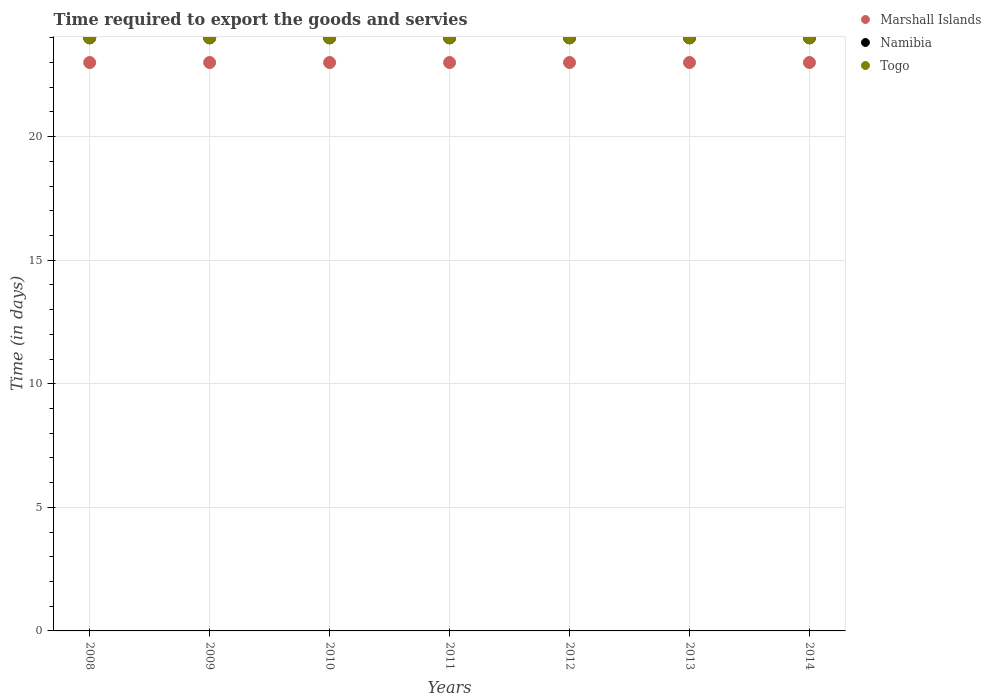What is the number of days required to export the goods and services in Namibia in 2014?
Give a very brief answer. 24. Across all years, what is the maximum number of days required to export the goods and services in Togo?
Your answer should be very brief. 24. Across all years, what is the minimum number of days required to export the goods and services in Marshall Islands?
Your response must be concise. 23. In which year was the number of days required to export the goods and services in Namibia minimum?
Keep it short and to the point. 2008. What is the total number of days required to export the goods and services in Togo in the graph?
Offer a very short reply. 168. What is the difference between the number of days required to export the goods and services in Togo in 2010 and that in 2013?
Your response must be concise. 0. What is the average number of days required to export the goods and services in Marshall Islands per year?
Provide a succinct answer. 23. In the year 2013, what is the difference between the number of days required to export the goods and services in Marshall Islands and number of days required to export the goods and services in Namibia?
Offer a terse response. -1. In how many years, is the number of days required to export the goods and services in Namibia greater than 6 days?
Make the answer very short. 7. What is the ratio of the number of days required to export the goods and services in Marshall Islands in 2008 to that in 2013?
Offer a terse response. 1. Is the difference between the number of days required to export the goods and services in Marshall Islands in 2012 and 2014 greater than the difference between the number of days required to export the goods and services in Namibia in 2012 and 2014?
Give a very brief answer. No. What is the difference between the highest and the lowest number of days required to export the goods and services in Namibia?
Provide a short and direct response. 0. Is the number of days required to export the goods and services in Togo strictly greater than the number of days required to export the goods and services in Namibia over the years?
Your answer should be very brief. No. How many dotlines are there?
Keep it short and to the point. 3. How many years are there in the graph?
Keep it short and to the point. 7. What is the difference between two consecutive major ticks on the Y-axis?
Provide a succinct answer. 5. Are the values on the major ticks of Y-axis written in scientific E-notation?
Your response must be concise. No. Does the graph contain grids?
Provide a short and direct response. Yes. Where does the legend appear in the graph?
Provide a short and direct response. Top right. How many legend labels are there?
Provide a short and direct response. 3. How are the legend labels stacked?
Make the answer very short. Vertical. What is the title of the graph?
Your response must be concise. Time required to export the goods and servies. Does "Vietnam" appear as one of the legend labels in the graph?
Your answer should be compact. No. What is the label or title of the Y-axis?
Your answer should be very brief. Time (in days). What is the Time (in days) in Namibia in 2008?
Offer a terse response. 24. What is the Time (in days) in Togo in 2008?
Keep it short and to the point. 24. What is the Time (in days) of Togo in 2009?
Provide a short and direct response. 24. What is the Time (in days) of Marshall Islands in 2010?
Give a very brief answer. 23. What is the Time (in days) in Namibia in 2010?
Your response must be concise. 24. What is the Time (in days) of Togo in 2010?
Offer a terse response. 24. What is the Time (in days) in Marshall Islands in 2011?
Provide a succinct answer. 23. What is the Time (in days) of Togo in 2011?
Provide a succinct answer. 24. What is the Time (in days) of Marshall Islands in 2012?
Offer a terse response. 23. What is the Time (in days) of Togo in 2012?
Your answer should be very brief. 24. What is the Time (in days) in Namibia in 2013?
Offer a very short reply. 24. What is the Time (in days) of Togo in 2013?
Offer a very short reply. 24. What is the Time (in days) of Marshall Islands in 2014?
Provide a succinct answer. 23. What is the Time (in days) in Namibia in 2014?
Offer a terse response. 24. Across all years, what is the maximum Time (in days) of Marshall Islands?
Your answer should be very brief. 23. Across all years, what is the maximum Time (in days) of Namibia?
Your answer should be compact. 24. Across all years, what is the minimum Time (in days) of Namibia?
Offer a very short reply. 24. What is the total Time (in days) in Marshall Islands in the graph?
Offer a terse response. 161. What is the total Time (in days) of Namibia in the graph?
Your answer should be very brief. 168. What is the total Time (in days) of Togo in the graph?
Ensure brevity in your answer.  168. What is the difference between the Time (in days) in Namibia in 2008 and that in 2009?
Make the answer very short. 0. What is the difference between the Time (in days) in Togo in 2008 and that in 2009?
Your response must be concise. 0. What is the difference between the Time (in days) in Marshall Islands in 2008 and that in 2010?
Keep it short and to the point. 0. What is the difference between the Time (in days) in Marshall Islands in 2008 and that in 2011?
Your answer should be very brief. 0. What is the difference between the Time (in days) in Togo in 2008 and that in 2011?
Your answer should be compact. 0. What is the difference between the Time (in days) in Marshall Islands in 2008 and that in 2012?
Offer a very short reply. 0. What is the difference between the Time (in days) in Marshall Islands in 2008 and that in 2014?
Your response must be concise. 0. What is the difference between the Time (in days) in Namibia in 2008 and that in 2014?
Keep it short and to the point. 0. What is the difference between the Time (in days) in Togo in 2009 and that in 2010?
Ensure brevity in your answer.  0. What is the difference between the Time (in days) of Marshall Islands in 2009 and that in 2011?
Give a very brief answer. 0. What is the difference between the Time (in days) in Namibia in 2009 and that in 2011?
Provide a short and direct response. 0. What is the difference between the Time (in days) of Togo in 2009 and that in 2011?
Offer a terse response. 0. What is the difference between the Time (in days) in Marshall Islands in 2009 and that in 2012?
Your response must be concise. 0. What is the difference between the Time (in days) of Namibia in 2009 and that in 2012?
Your answer should be compact. 0. What is the difference between the Time (in days) of Togo in 2009 and that in 2012?
Keep it short and to the point. 0. What is the difference between the Time (in days) of Marshall Islands in 2009 and that in 2014?
Make the answer very short. 0. What is the difference between the Time (in days) in Togo in 2009 and that in 2014?
Provide a short and direct response. 0. What is the difference between the Time (in days) of Marshall Islands in 2010 and that in 2012?
Ensure brevity in your answer.  0. What is the difference between the Time (in days) of Namibia in 2010 and that in 2013?
Provide a short and direct response. 0. What is the difference between the Time (in days) in Namibia in 2010 and that in 2014?
Provide a short and direct response. 0. What is the difference between the Time (in days) of Marshall Islands in 2011 and that in 2012?
Provide a succinct answer. 0. What is the difference between the Time (in days) of Marshall Islands in 2011 and that in 2014?
Keep it short and to the point. 0. What is the difference between the Time (in days) in Namibia in 2011 and that in 2014?
Your response must be concise. 0. What is the difference between the Time (in days) in Togo in 2011 and that in 2014?
Provide a short and direct response. 0. What is the difference between the Time (in days) of Marshall Islands in 2012 and that in 2013?
Your answer should be very brief. 0. What is the difference between the Time (in days) of Togo in 2012 and that in 2013?
Ensure brevity in your answer.  0. What is the difference between the Time (in days) of Marshall Islands in 2012 and that in 2014?
Ensure brevity in your answer.  0. What is the difference between the Time (in days) of Togo in 2012 and that in 2014?
Keep it short and to the point. 0. What is the difference between the Time (in days) of Marshall Islands in 2013 and that in 2014?
Provide a succinct answer. 0. What is the difference between the Time (in days) in Namibia in 2013 and that in 2014?
Provide a succinct answer. 0. What is the difference between the Time (in days) in Togo in 2013 and that in 2014?
Offer a terse response. 0. What is the difference between the Time (in days) of Marshall Islands in 2008 and the Time (in days) of Togo in 2009?
Your answer should be compact. -1. What is the difference between the Time (in days) in Namibia in 2008 and the Time (in days) in Togo in 2009?
Keep it short and to the point. 0. What is the difference between the Time (in days) of Marshall Islands in 2008 and the Time (in days) of Namibia in 2010?
Offer a very short reply. -1. What is the difference between the Time (in days) of Marshall Islands in 2008 and the Time (in days) of Togo in 2010?
Make the answer very short. -1. What is the difference between the Time (in days) of Marshall Islands in 2008 and the Time (in days) of Namibia in 2012?
Keep it short and to the point. -1. What is the difference between the Time (in days) of Namibia in 2008 and the Time (in days) of Togo in 2012?
Ensure brevity in your answer.  0. What is the difference between the Time (in days) in Marshall Islands in 2008 and the Time (in days) in Togo in 2013?
Your answer should be compact. -1. What is the difference between the Time (in days) in Namibia in 2008 and the Time (in days) in Togo in 2013?
Provide a succinct answer. 0. What is the difference between the Time (in days) of Marshall Islands in 2008 and the Time (in days) of Namibia in 2014?
Keep it short and to the point. -1. What is the difference between the Time (in days) of Marshall Islands in 2009 and the Time (in days) of Namibia in 2010?
Provide a succinct answer. -1. What is the difference between the Time (in days) in Marshall Islands in 2009 and the Time (in days) in Togo in 2010?
Make the answer very short. -1. What is the difference between the Time (in days) of Namibia in 2009 and the Time (in days) of Togo in 2010?
Your answer should be very brief. 0. What is the difference between the Time (in days) of Marshall Islands in 2009 and the Time (in days) of Namibia in 2011?
Your response must be concise. -1. What is the difference between the Time (in days) in Marshall Islands in 2009 and the Time (in days) in Namibia in 2012?
Ensure brevity in your answer.  -1. What is the difference between the Time (in days) in Namibia in 2009 and the Time (in days) in Togo in 2014?
Provide a short and direct response. 0. What is the difference between the Time (in days) of Namibia in 2010 and the Time (in days) of Togo in 2011?
Provide a succinct answer. 0. What is the difference between the Time (in days) in Namibia in 2010 and the Time (in days) in Togo in 2012?
Provide a succinct answer. 0. What is the difference between the Time (in days) in Marshall Islands in 2010 and the Time (in days) in Namibia in 2013?
Your answer should be compact. -1. What is the difference between the Time (in days) in Marshall Islands in 2010 and the Time (in days) in Togo in 2013?
Your answer should be compact. -1. What is the difference between the Time (in days) in Marshall Islands in 2010 and the Time (in days) in Namibia in 2014?
Offer a terse response. -1. What is the difference between the Time (in days) of Marshall Islands in 2011 and the Time (in days) of Namibia in 2012?
Your answer should be compact. -1. What is the difference between the Time (in days) in Marshall Islands in 2011 and the Time (in days) in Togo in 2012?
Your answer should be compact. -1. What is the difference between the Time (in days) in Marshall Islands in 2011 and the Time (in days) in Namibia in 2013?
Provide a succinct answer. -1. What is the difference between the Time (in days) of Marshall Islands in 2011 and the Time (in days) of Togo in 2013?
Offer a terse response. -1. What is the difference between the Time (in days) of Namibia in 2011 and the Time (in days) of Togo in 2013?
Provide a short and direct response. 0. What is the difference between the Time (in days) in Marshall Islands in 2011 and the Time (in days) in Togo in 2014?
Provide a short and direct response. -1. What is the difference between the Time (in days) of Namibia in 2011 and the Time (in days) of Togo in 2014?
Give a very brief answer. 0. What is the difference between the Time (in days) of Marshall Islands in 2012 and the Time (in days) of Namibia in 2014?
Provide a short and direct response. -1. What is the difference between the Time (in days) of Marshall Islands in 2012 and the Time (in days) of Togo in 2014?
Ensure brevity in your answer.  -1. What is the difference between the Time (in days) of Marshall Islands in 2013 and the Time (in days) of Togo in 2014?
Offer a very short reply. -1. What is the difference between the Time (in days) in Namibia in 2013 and the Time (in days) in Togo in 2014?
Offer a terse response. 0. What is the average Time (in days) in Marshall Islands per year?
Your answer should be very brief. 23. What is the average Time (in days) of Togo per year?
Offer a very short reply. 24. In the year 2008, what is the difference between the Time (in days) of Marshall Islands and Time (in days) of Togo?
Your response must be concise. -1. In the year 2009, what is the difference between the Time (in days) in Namibia and Time (in days) in Togo?
Your answer should be very brief. 0. In the year 2010, what is the difference between the Time (in days) in Marshall Islands and Time (in days) in Namibia?
Your response must be concise. -1. In the year 2010, what is the difference between the Time (in days) of Namibia and Time (in days) of Togo?
Make the answer very short. 0. In the year 2011, what is the difference between the Time (in days) in Marshall Islands and Time (in days) in Namibia?
Keep it short and to the point. -1. In the year 2011, what is the difference between the Time (in days) in Marshall Islands and Time (in days) in Togo?
Your answer should be very brief. -1. In the year 2012, what is the difference between the Time (in days) in Marshall Islands and Time (in days) in Togo?
Keep it short and to the point. -1. In the year 2013, what is the difference between the Time (in days) in Marshall Islands and Time (in days) in Namibia?
Your response must be concise. -1. In the year 2013, what is the difference between the Time (in days) of Marshall Islands and Time (in days) of Togo?
Your answer should be very brief. -1. In the year 2014, what is the difference between the Time (in days) in Marshall Islands and Time (in days) in Namibia?
Provide a short and direct response. -1. In the year 2014, what is the difference between the Time (in days) of Marshall Islands and Time (in days) of Togo?
Offer a terse response. -1. What is the ratio of the Time (in days) of Marshall Islands in 2008 to that in 2009?
Offer a very short reply. 1. What is the ratio of the Time (in days) in Namibia in 2008 to that in 2009?
Give a very brief answer. 1. What is the ratio of the Time (in days) in Marshall Islands in 2008 to that in 2010?
Keep it short and to the point. 1. What is the ratio of the Time (in days) in Togo in 2008 to that in 2010?
Keep it short and to the point. 1. What is the ratio of the Time (in days) in Marshall Islands in 2008 to that in 2011?
Give a very brief answer. 1. What is the ratio of the Time (in days) in Togo in 2008 to that in 2011?
Give a very brief answer. 1. What is the ratio of the Time (in days) in Marshall Islands in 2008 to that in 2012?
Provide a short and direct response. 1. What is the ratio of the Time (in days) of Namibia in 2008 to that in 2012?
Your answer should be compact. 1. What is the ratio of the Time (in days) in Togo in 2008 to that in 2012?
Offer a terse response. 1. What is the ratio of the Time (in days) in Marshall Islands in 2008 to that in 2013?
Give a very brief answer. 1. What is the ratio of the Time (in days) in Namibia in 2008 to that in 2013?
Your answer should be compact. 1. What is the ratio of the Time (in days) of Namibia in 2008 to that in 2014?
Offer a terse response. 1. What is the ratio of the Time (in days) in Togo in 2008 to that in 2014?
Your answer should be compact. 1. What is the ratio of the Time (in days) in Namibia in 2009 to that in 2010?
Provide a succinct answer. 1. What is the ratio of the Time (in days) of Togo in 2009 to that in 2010?
Offer a terse response. 1. What is the ratio of the Time (in days) in Marshall Islands in 2009 to that in 2011?
Your response must be concise. 1. What is the ratio of the Time (in days) of Namibia in 2009 to that in 2012?
Offer a very short reply. 1. What is the ratio of the Time (in days) in Togo in 2009 to that in 2013?
Provide a succinct answer. 1. What is the ratio of the Time (in days) in Marshall Islands in 2009 to that in 2014?
Give a very brief answer. 1. What is the ratio of the Time (in days) in Namibia in 2009 to that in 2014?
Your response must be concise. 1. What is the ratio of the Time (in days) in Togo in 2009 to that in 2014?
Your response must be concise. 1. What is the ratio of the Time (in days) in Marshall Islands in 2010 to that in 2011?
Ensure brevity in your answer.  1. What is the ratio of the Time (in days) in Namibia in 2010 to that in 2012?
Provide a succinct answer. 1. What is the ratio of the Time (in days) in Togo in 2010 to that in 2013?
Provide a succinct answer. 1. What is the ratio of the Time (in days) of Togo in 2010 to that in 2014?
Your answer should be very brief. 1. What is the ratio of the Time (in days) of Togo in 2011 to that in 2012?
Your answer should be very brief. 1. What is the ratio of the Time (in days) in Namibia in 2011 to that in 2013?
Offer a terse response. 1. What is the ratio of the Time (in days) of Togo in 2011 to that in 2013?
Give a very brief answer. 1. What is the ratio of the Time (in days) of Namibia in 2011 to that in 2014?
Make the answer very short. 1. What is the ratio of the Time (in days) of Togo in 2011 to that in 2014?
Make the answer very short. 1. What is the ratio of the Time (in days) in Togo in 2012 to that in 2013?
Your response must be concise. 1. What is the ratio of the Time (in days) in Namibia in 2012 to that in 2014?
Keep it short and to the point. 1. What is the ratio of the Time (in days) in Togo in 2012 to that in 2014?
Provide a short and direct response. 1. What is the ratio of the Time (in days) of Namibia in 2013 to that in 2014?
Your response must be concise. 1. What is the difference between the highest and the second highest Time (in days) of Marshall Islands?
Your response must be concise. 0. What is the difference between the highest and the second highest Time (in days) in Togo?
Offer a very short reply. 0. 